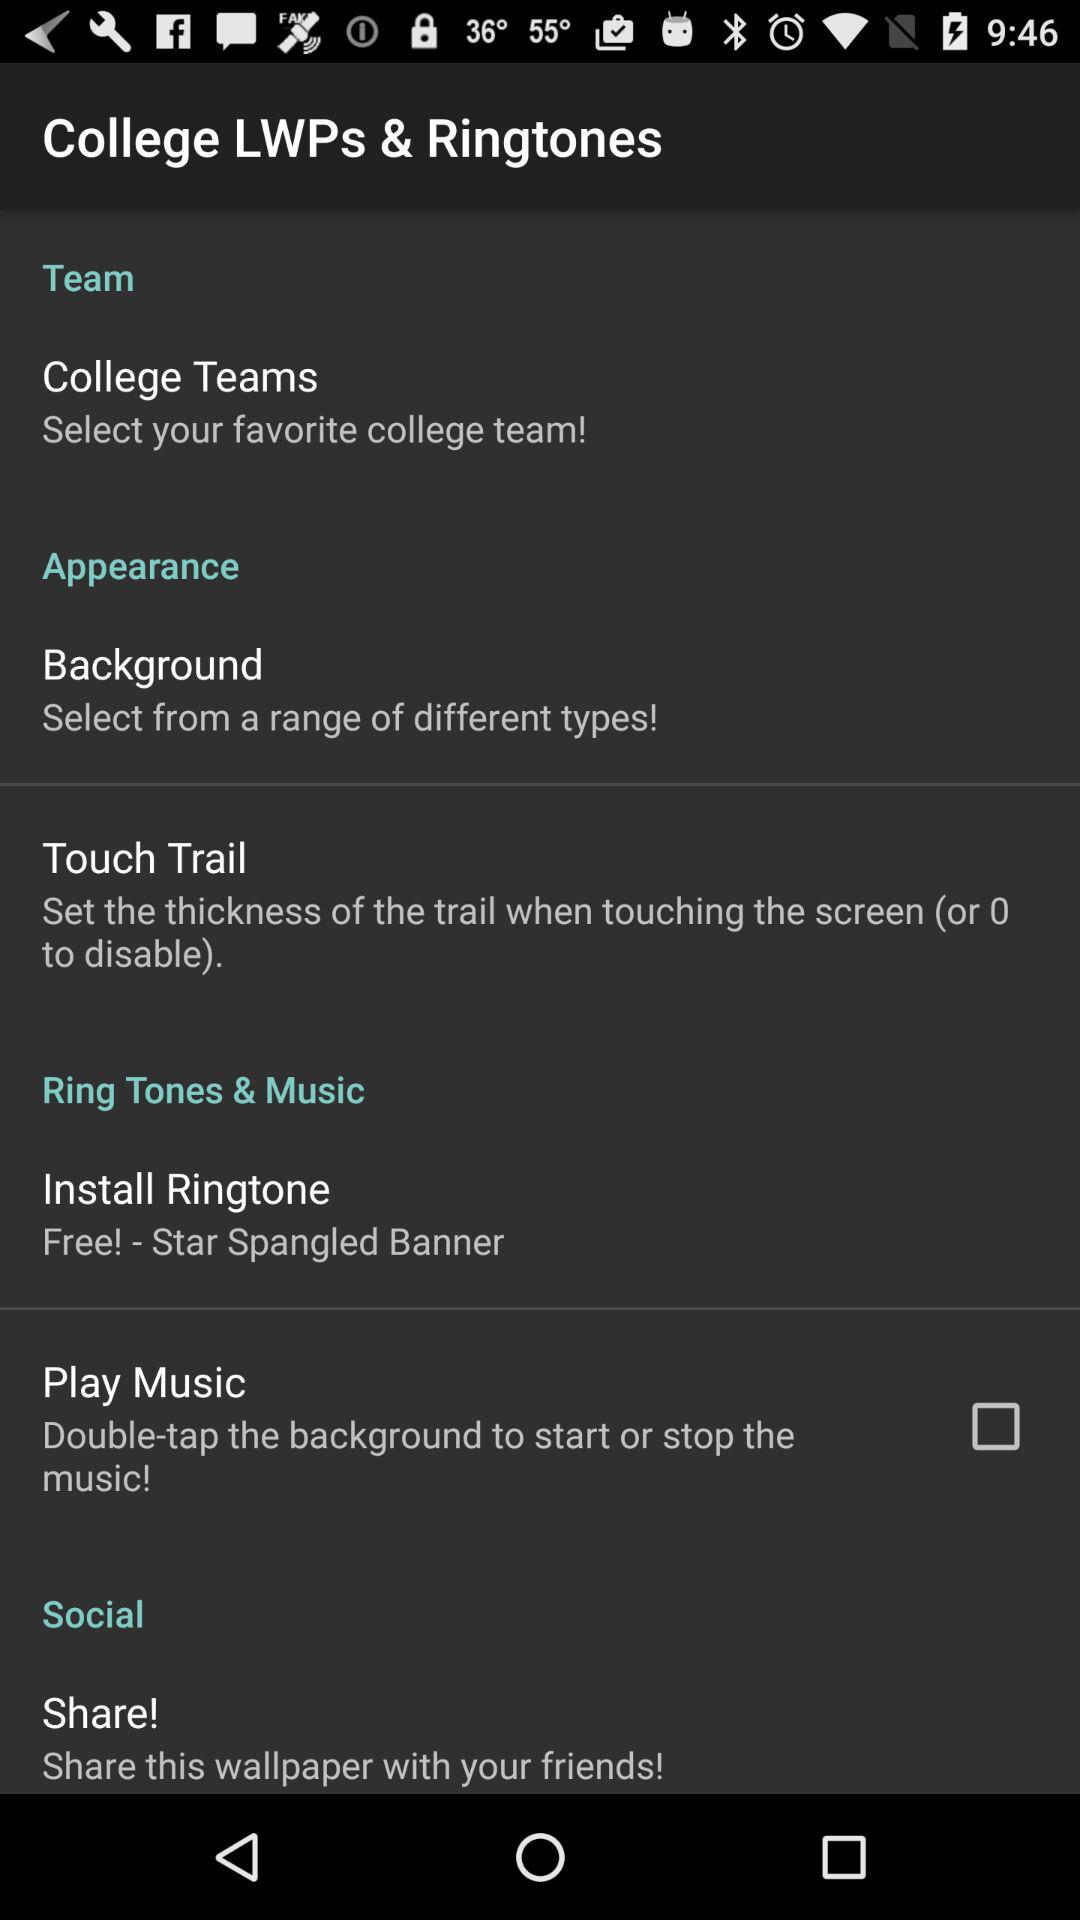How many items in the Ring Tones & Music section have a checkbox?
Answer the question using a single word or phrase. 1 